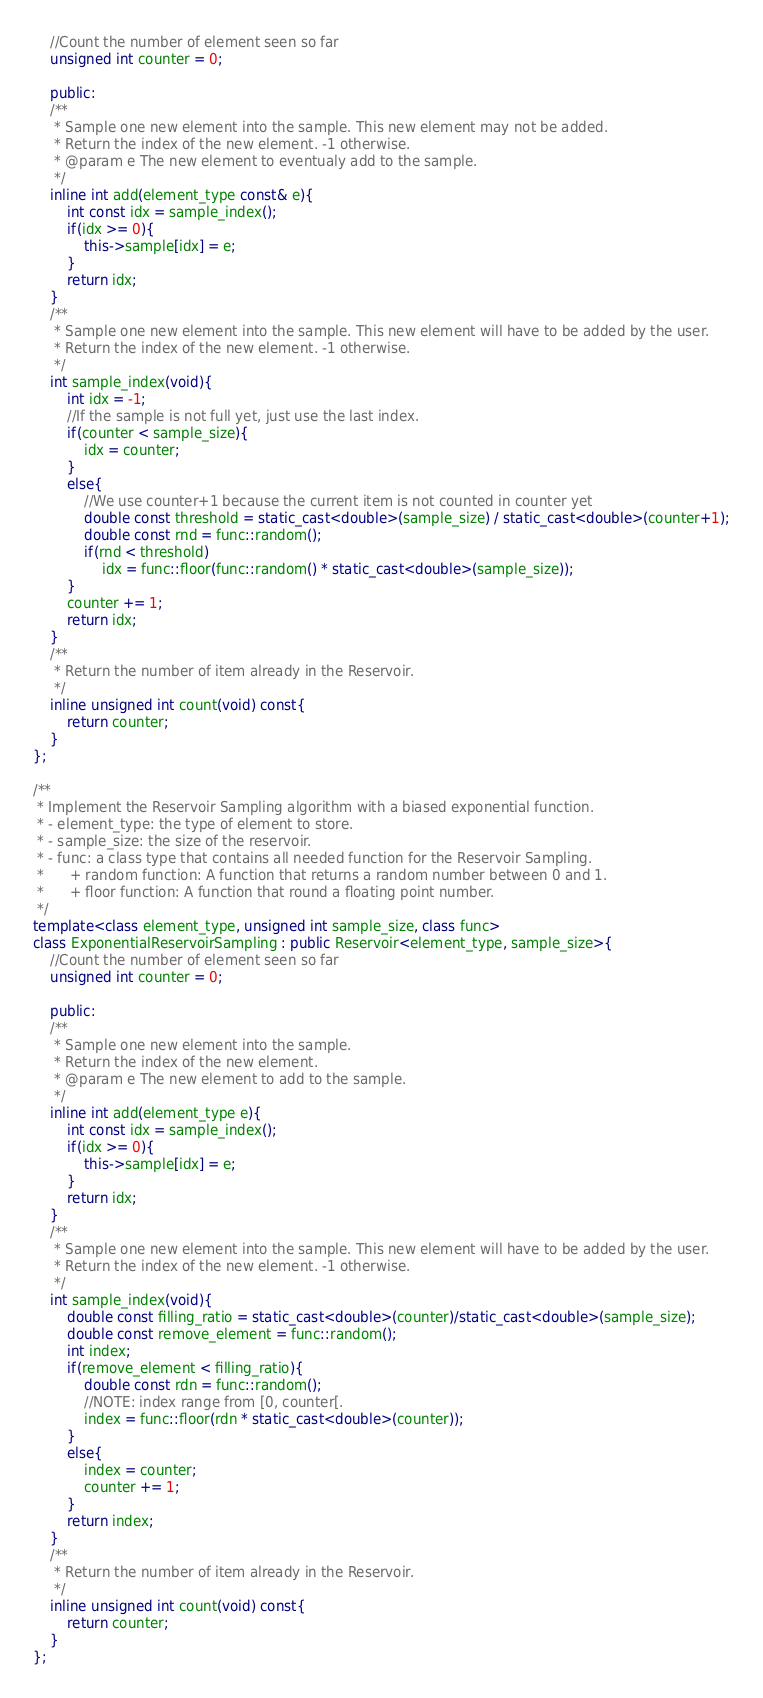<code> <loc_0><loc_0><loc_500><loc_500><_C++_>	//Count the number of element seen so far
	unsigned int counter = 0;

	public:
	/**
	 * Sample one new element into the sample. This new element may not be added.
	 * Return the index of the new element. -1 otherwise.
	 * @param e The new element to eventualy add to the sample.
	 */
	inline int add(element_type const& e){
		int const idx = sample_index();
		if(idx >= 0){
			this->sample[idx] = e;
		}
		return idx;
	}
	/**
	 * Sample one new element into the sample. This new element will have to be added by the user.
	 * Return the index of the new element. -1 otherwise.
	 */
	int sample_index(void){
		int idx = -1;
		//If the sample is not full yet, just use the last index.
		if(counter < sample_size){
			idx = counter;
		}
		else{
			//We use counter+1 because the current item is not counted in counter yet
			double const threshold = static_cast<double>(sample_size) / static_cast<double>(counter+1);
			double const rnd = func::random();
			if(rnd < threshold)
				idx = func::floor(func::random() * static_cast<double>(sample_size));
		}
		counter += 1;
		return idx;
	}
	/**
	 * Return the number of item already in the Reservoir.
	 */
	inline unsigned int count(void) const{
		return counter;
	}
};

/**
 * Implement the Reservoir Sampling algorithm with a biased exponential function.
 * - element_type: the type of element to store.
 * - sample_size: the size of the reservoir.
 * - func: a class type that contains all needed function for the Reservoir Sampling.
 *   	+ random function: A function that returns a random number between 0 and 1.
 *   	+ floor function: A function that round a floating point number.
 */
template<class element_type, unsigned int sample_size, class func>
class ExponentialReservoirSampling : public Reservoir<element_type, sample_size>{
	//Count the number of element seen so far
	unsigned int counter = 0;

	public:
	/**
	 * Sample one new element into the sample.
	 * Return the index of the new element. 
	 * @param e The new element to add to the sample.
	 */
	inline int add(element_type e){
		int const idx = sample_index();
		if(idx >= 0){
			this->sample[idx] = e;
		}
		return idx;
	}
	/**
	 * Sample one new element into the sample. This new element will have to be added by the user.
	 * Return the index of the new element. -1 otherwise.
	 */
	int sample_index(void){
		double const filling_ratio = static_cast<double>(counter)/static_cast<double>(sample_size);
		double const remove_element = func::random();
		int index;
		if(remove_element < filling_ratio){
			double const rdn = func::random();
			//NOTE: index range from [0, counter[.
			index = func::floor(rdn * static_cast<double>(counter));
		}
		else{
			index = counter;
			counter += 1;
		}
		return index;
	}
	/**
	 * Return the number of item already in the Reservoir.
	 */
	inline unsigned int count(void) const{
		return counter;
	}
};
</code> 